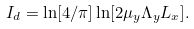<formula> <loc_0><loc_0><loc_500><loc_500>I _ { d } = \ln [ 4 / \pi ] \ln [ 2 \mu _ { y } \Lambda _ { y } L _ { x } ] .</formula> 